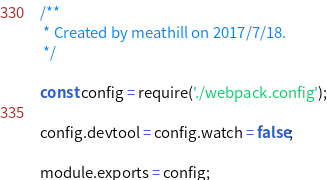Convert code to text. <code><loc_0><loc_0><loc_500><loc_500><_JavaScript_>/**
 * Created by meathill on 2017/7/18.
 */

const config = require('./webpack.config');

config.devtool = config.watch = false;

module.exports = config;</code> 